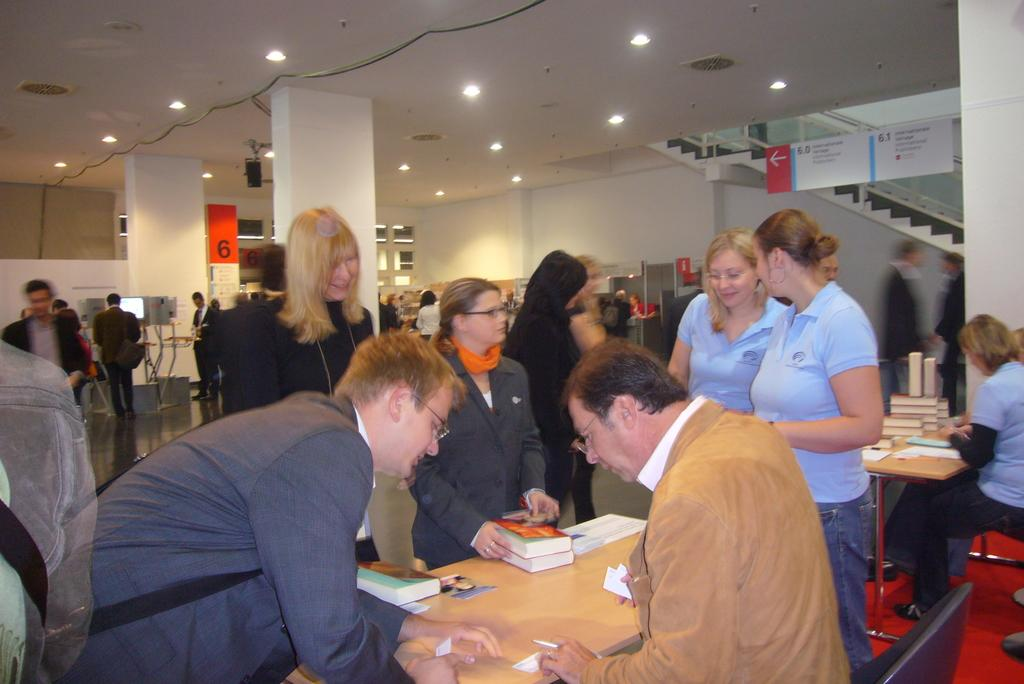What type of furniture is present in the image? There is at least one table in the image. What items can be seen on the table? There are books in the image. Can you describe the people in the image? There are people in the image. What architectural feature is visible in the image? There are stairs in the image. What safety feature is present near the stairs? There is a railing in the image. What type of structure is depicted in the image? There are walls in the image. What type of lighting is present in the image? There are lights in the image. What type of floor covering is present in the image? There is a floor mat in the image. What other objects can be seen in the image? There are other objects in the image. What type of industry is being conducted in the image? There is no indication of any industry in the image. What type of account is being managed in the image? There is no mention of any account in the image. 